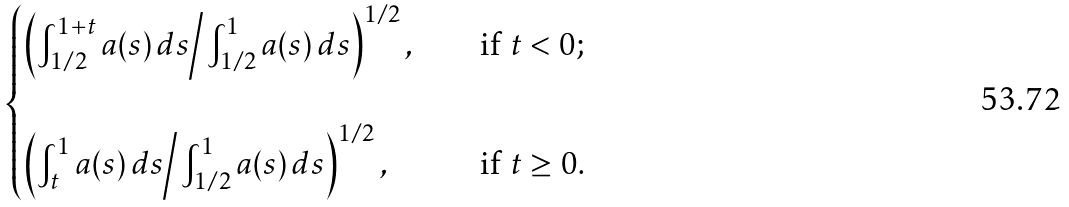Convert formula to latex. <formula><loc_0><loc_0><loc_500><loc_500>\begin{cases} \left ( \int _ { 1 / 2 } ^ { 1 + t } a ( s ) \, d s \Big / \int ^ { 1 } _ { 1 / 2 } a ( s ) \, d s \right ) ^ { 1 / 2 } , \quad & \text {if $t<0$;} \\ & \\ \left ( \int _ { t } ^ { 1 } a ( s ) \, d s \Big / \int ^ { 1 } _ { 1 / 2 } a ( s ) \, d s \right ) ^ { 1 / 2 } , \quad & \text {if $t\geq 0$} . \end{cases}</formula> 